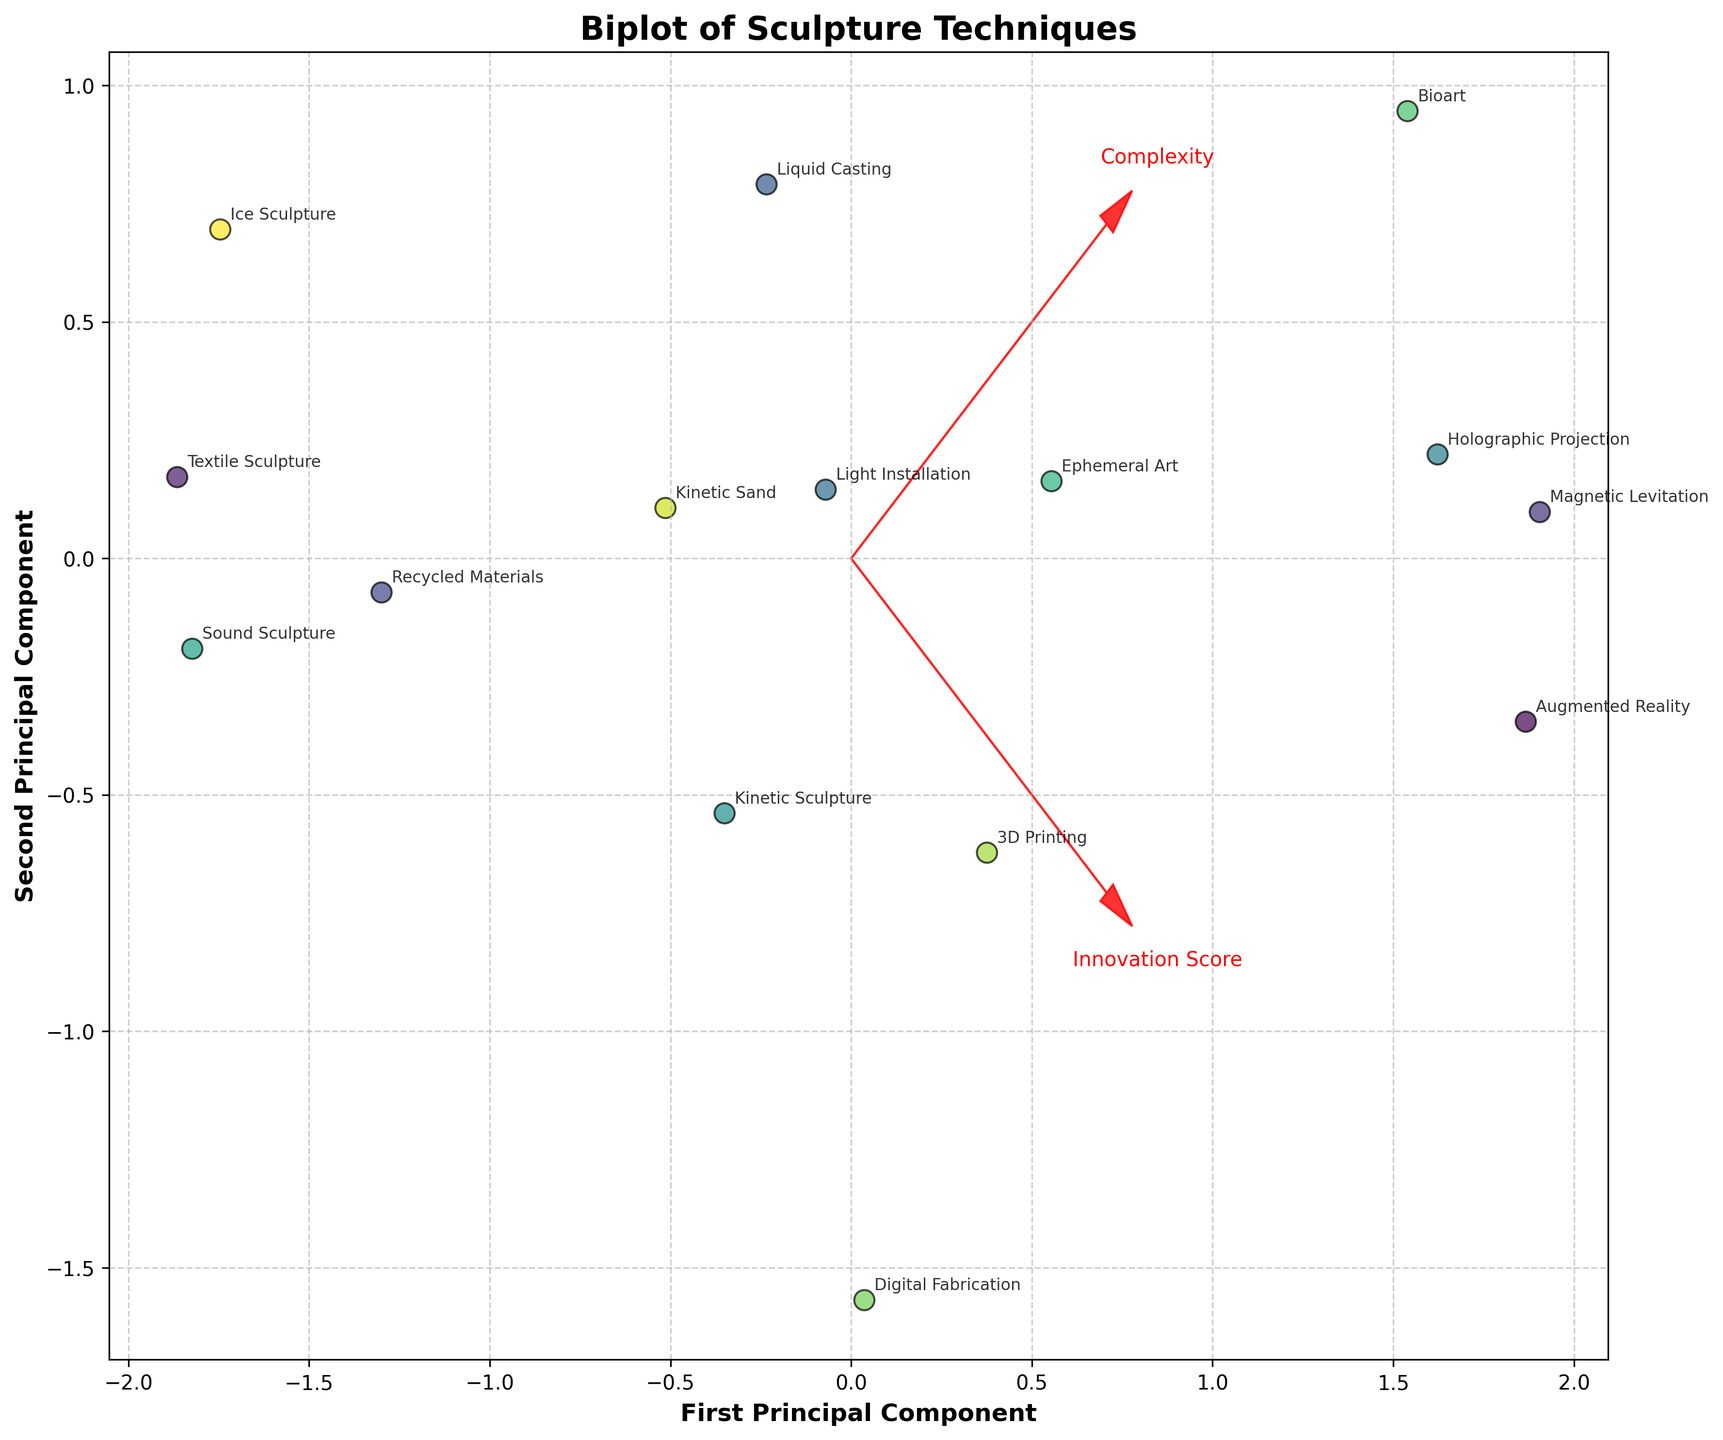What is the title of the biplot? Looking at the top section of the figure will give the title. The title is usually displayed in a larger font compared to other text elements.
Answer: Biplot of Sculpture Techniques What are the labels of the two principal components? Check the x-axis and y-axis labels to identify the names given to the two components derived from PCA.
Answer: First Principal Component, Second Principal Component How many techniques are plotted in the biplot? Count the number of distinct data points labeled with technique names in the biplot. Each data point represents a technique.
Answer: 15 Which material type has the highest Innovation Score and Complexity combination? Locate the data point farthest in the direction of both Innovation Score and Complexity vectors. Identify the corresponding technique and material type.
Answer: Ferromagnetic Materials (Magnetic Levitation) Do materials from "Fine Arts" and "Culinary Arts" backgrounds overlap in the plot? Check the scatterplot for the positions of the Fine Arts and Culinary Arts data points. Observe if their locations are the same or very close, indicating overlap.
Answer: No What is the relationship between Innovation Score and Complexity in the plot? Examine the direction and length of the vectors representing Innovation Score and Complexity. Analyze if they point in the same, opposite, or different directions to deduce the relationship.
Answer: Positive correlation Which technique involves the most complex material according to the biplot? Look at the direction and length of the Complexity vector and find the technique label closest to the highest point along this vector.
Answer: Bioart (Organic Matter) How does the Digital Fabrication technique compare to the Augmented Reality technique in terms of principal components? Locate both techniques on the biplot. Compare their positions in relation to the First and Second Principal Components.
Answer: Digital Fabrication has a lower Innovation Score but similar Complexity compared to Augmented Reality Which materials cluster close to the origin in the biplot? Identify the data points that are located near the intersection of the First and Second Principal Components (the origin). List the corresponding materials.
Answer: Fabric (Textile Sculpture), Found Objects (Recycled Materials) What can be inferred about "LED" material based on its position on the biplot? Determine the location of the LED material (Light Installation) in relation to the Innovation Score and Complexity vectors. Analyze its relative position to infer innovation and complexity characteristics.
Answer: LED material is moderately innovative and complex 